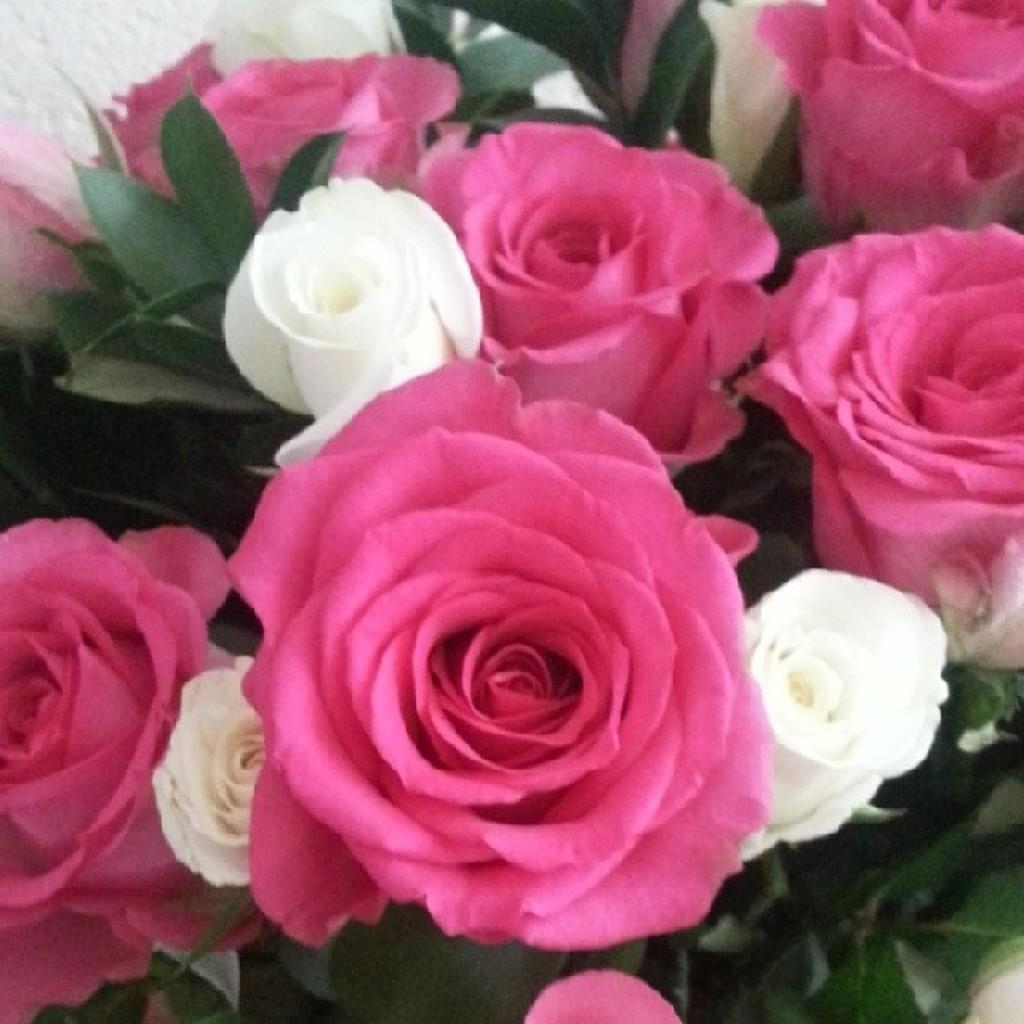What type of plant life can be seen in the image? There are flowers and leaves in the image. Can you describe the appearance of the flowers? Unfortunately, the specific appearance of the flowers cannot be determined from the provided facts. Are there any other elements present in the image besides the flowers and leaves? No additional elements are mentioned in the provided facts. Can you describe the monkey playing in the ocean in the image? There is no monkey or ocean present in the image; it only features flowers and leaves. 